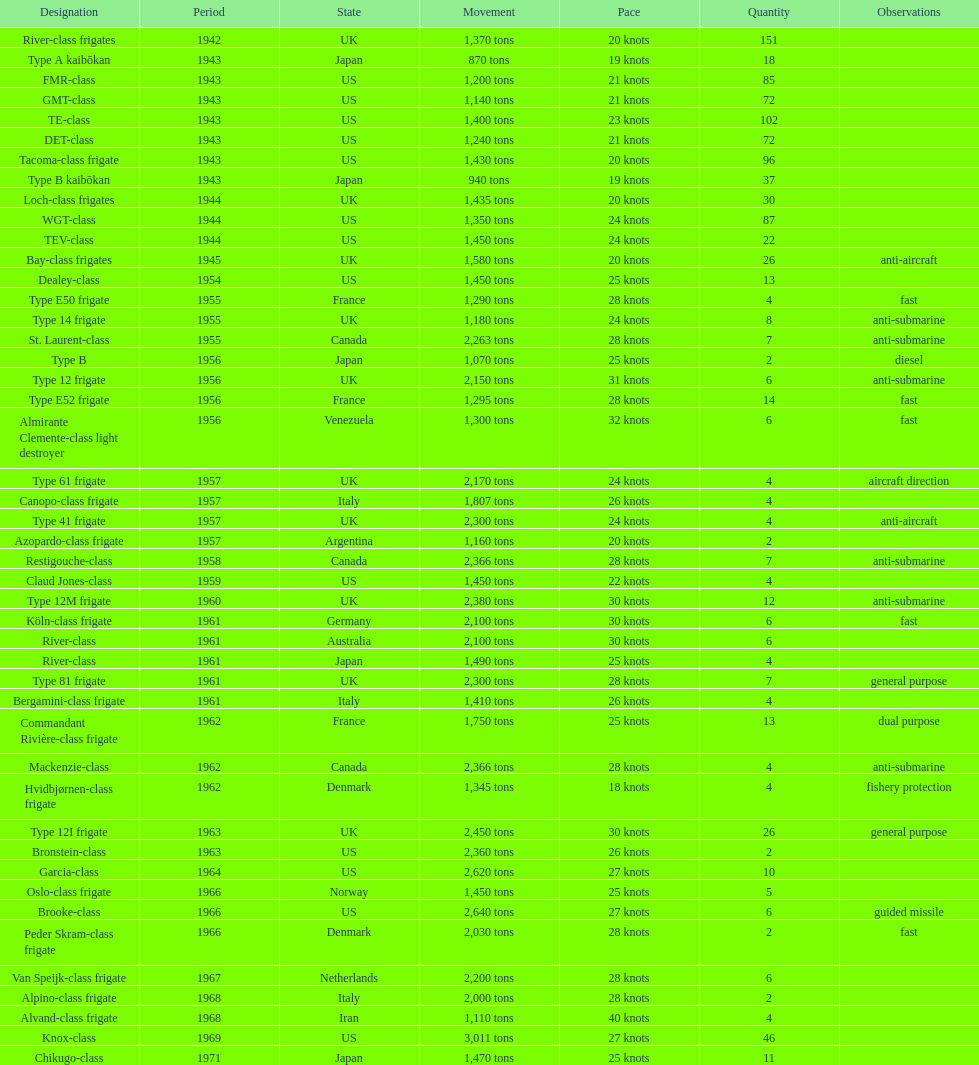In 1968 italy used alpino-class frigate. what was its top speed? 28 knots. 